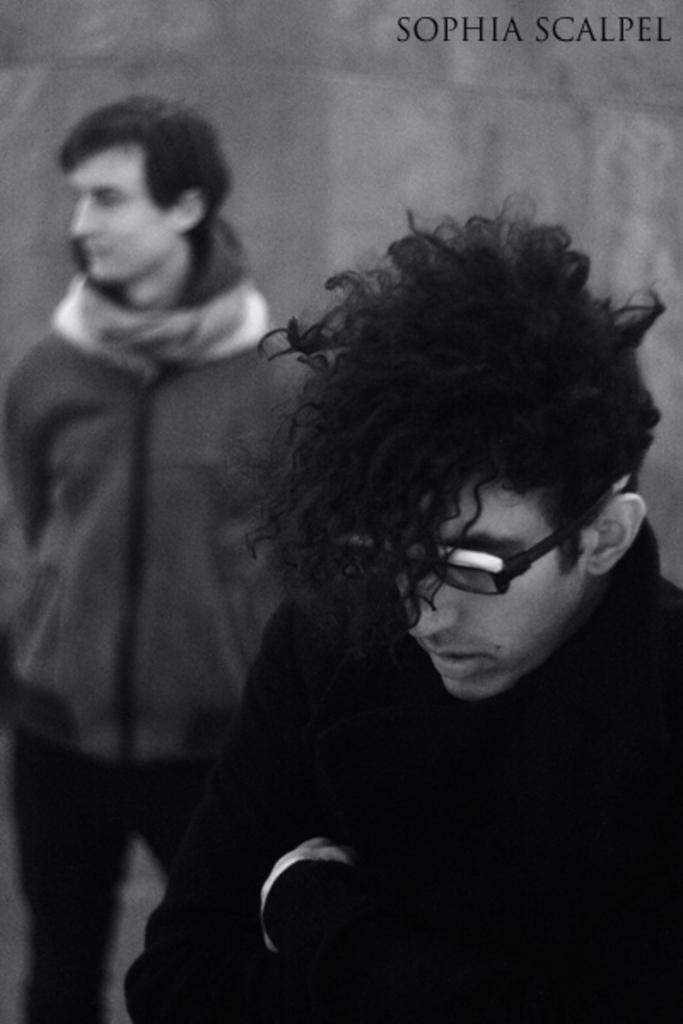What is the color scheme of the image? The image is black and white. How many people are in the image? There are two men standing in the image. What can be observed about the background in the image? The background behind the men is blurred. Is there any additional information or marking on the image? Yes, there is a watermark on the image. What type of canvas is being used by the men in the image? There is no canvas present in the image, and the men are not using any canvas. Can you see any hammers or trucks in the image? No, there are no hammers or trucks visible in the image. 